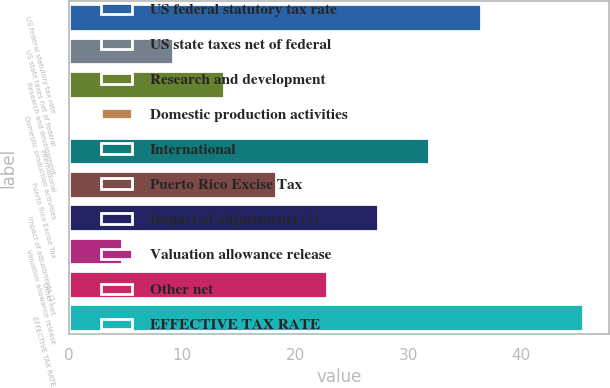Convert chart. <chart><loc_0><loc_0><loc_500><loc_500><bar_chart><fcel>US federal statutory tax rate<fcel>US state taxes net of federal<fcel>Research and development<fcel>Domestic production activities<fcel>International<fcel>Puerto Rico Excise Tax<fcel>Impact of adjustments (1)<fcel>Valuation allowance release<fcel>Other net<fcel>EFFECTIVE TAX RATE<nl><fcel>36.42<fcel>9.18<fcel>13.72<fcel>0.1<fcel>31.88<fcel>18.26<fcel>27.34<fcel>4.64<fcel>22.8<fcel>45.5<nl></chart> 